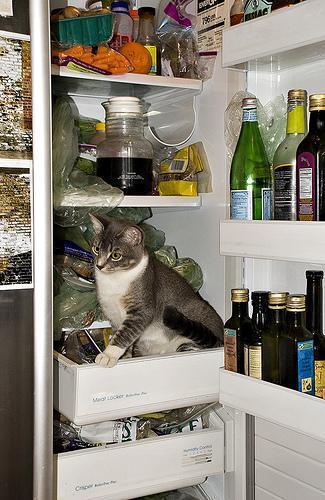How many cats can be seen?
Give a very brief answer. 1. How many bottles are in the picture?
Give a very brief answer. 5. 